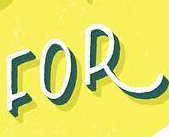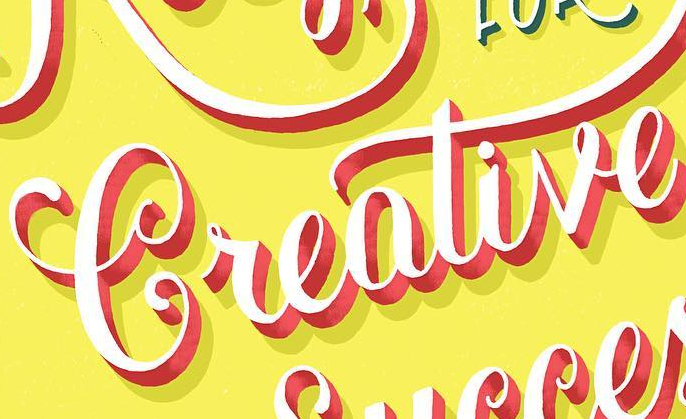What text appears in these images from left to right, separated by a semicolon? FOR; Creative 